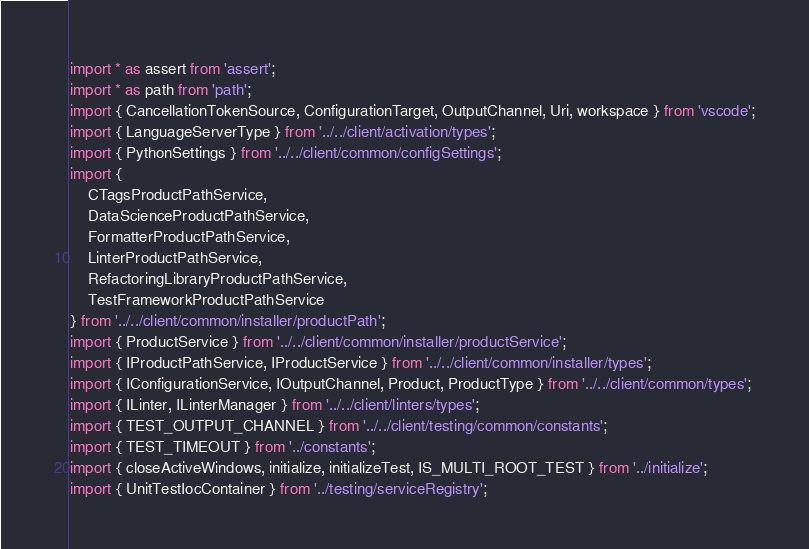<code> <loc_0><loc_0><loc_500><loc_500><_TypeScript_>import * as assert from 'assert';
import * as path from 'path';
import { CancellationTokenSource, ConfigurationTarget, OutputChannel, Uri, workspace } from 'vscode';
import { LanguageServerType } from '../../client/activation/types';
import { PythonSettings } from '../../client/common/configSettings';
import {
    CTagsProductPathService,
    DataScienceProductPathService,
    FormatterProductPathService,
    LinterProductPathService,
    RefactoringLibraryProductPathService,
    TestFrameworkProductPathService
} from '../../client/common/installer/productPath';
import { ProductService } from '../../client/common/installer/productService';
import { IProductPathService, IProductService } from '../../client/common/installer/types';
import { IConfigurationService, IOutputChannel, Product, ProductType } from '../../client/common/types';
import { ILinter, ILinterManager } from '../../client/linters/types';
import { TEST_OUTPUT_CHANNEL } from '../../client/testing/common/constants';
import { TEST_TIMEOUT } from '../constants';
import { closeActiveWindows, initialize, initializeTest, IS_MULTI_ROOT_TEST } from '../initialize';
import { UnitTestIocContainer } from '../testing/serviceRegistry';
</code> 